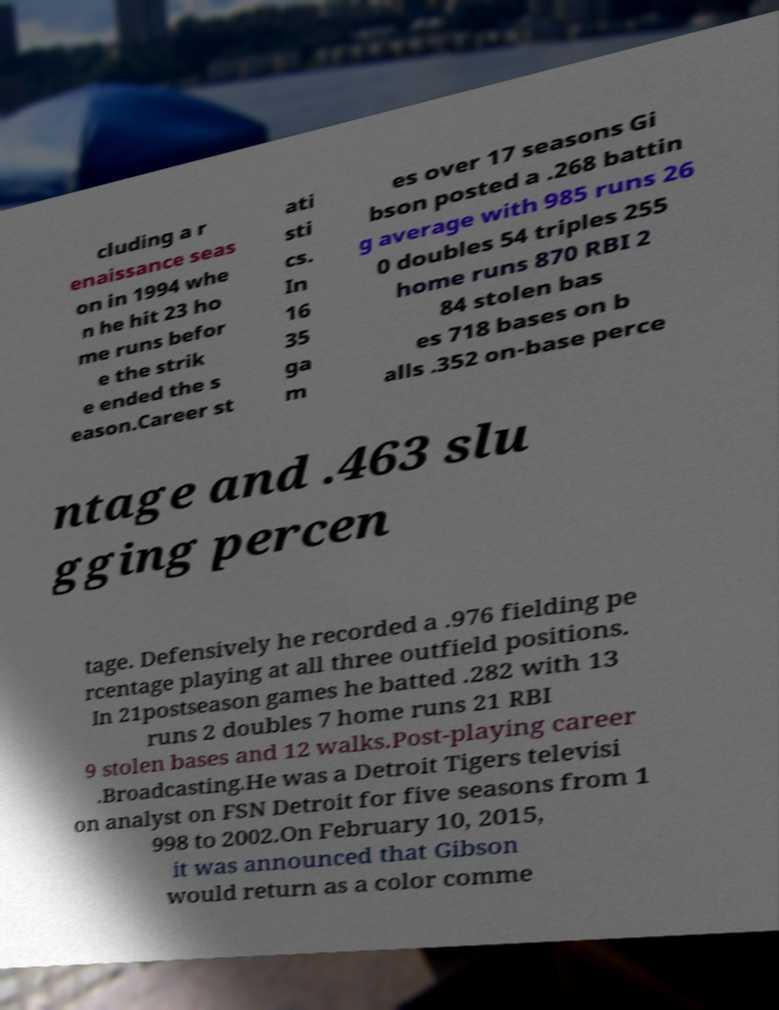Can you accurately transcribe the text from the provided image for me? cluding a r enaissance seas on in 1994 whe n he hit 23 ho me runs befor e the strik e ended the s eason.Career st ati sti cs. In 16 35 ga m es over 17 seasons Gi bson posted a .268 battin g average with 985 runs 26 0 doubles 54 triples 255 home runs 870 RBI 2 84 stolen bas es 718 bases on b alls .352 on-base perce ntage and .463 slu gging percen tage. Defensively he recorded a .976 fielding pe rcentage playing at all three outfield positions. In 21postseason games he batted .282 with 13 runs 2 doubles 7 home runs 21 RBI 9 stolen bases and 12 walks.Post-playing career .Broadcasting.He was a Detroit Tigers televisi on analyst on FSN Detroit for five seasons from 1 998 to 2002.On February 10, 2015, it was announced that Gibson would return as a color comme 